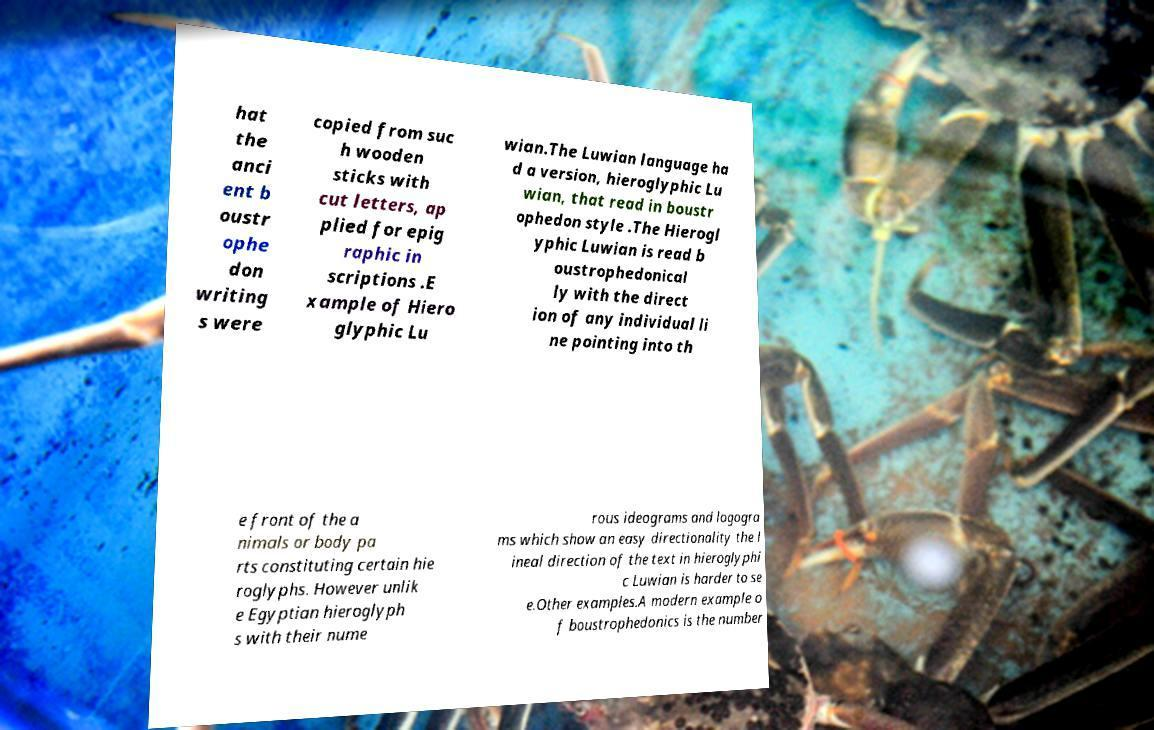Can you accurately transcribe the text from the provided image for me? hat the anci ent b oustr ophe don writing s were copied from suc h wooden sticks with cut letters, ap plied for epig raphic in scriptions .E xample of Hiero glyphic Lu wian.The Luwian language ha d a version, hieroglyphic Lu wian, that read in boustr ophedon style .The Hierogl yphic Luwian is read b oustrophedonical ly with the direct ion of any individual li ne pointing into th e front of the a nimals or body pa rts constituting certain hie roglyphs. However unlik e Egyptian hieroglyph s with their nume rous ideograms and logogra ms which show an easy directionality the l ineal direction of the text in hieroglyphi c Luwian is harder to se e.Other examples.A modern example o f boustrophedonics is the number 